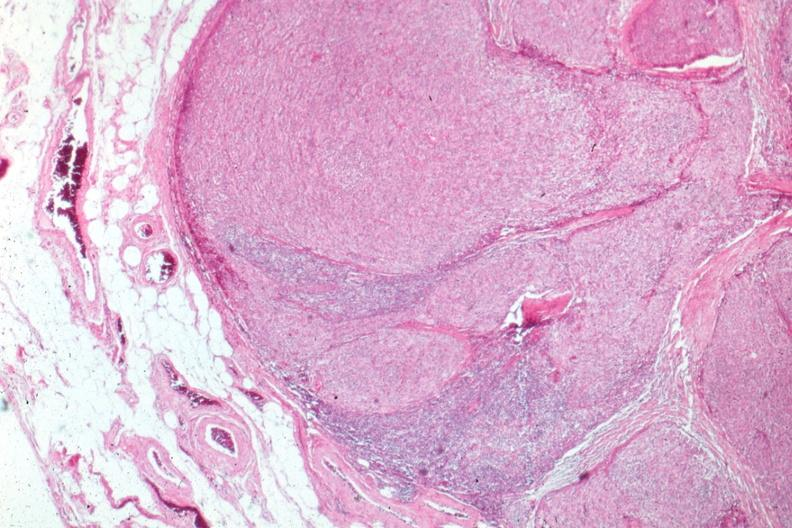s focal hemorrhagic infarction well shown present?
Answer the question using a single word or phrase. No 